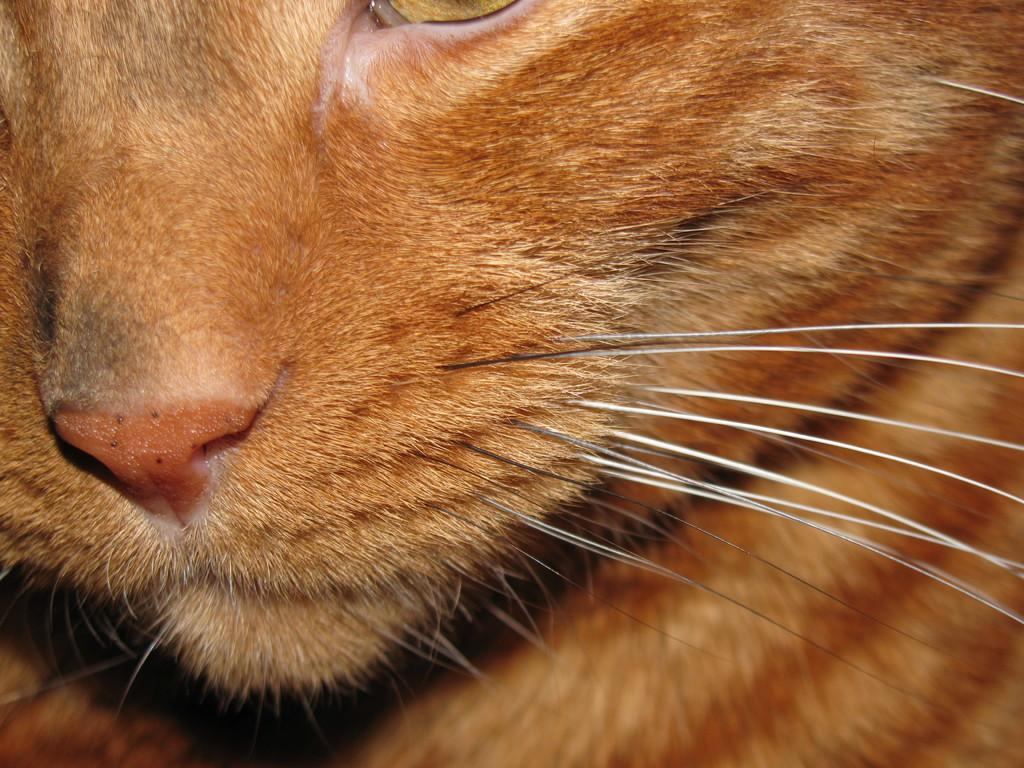What type of animal is in the image? There is a cat in the image. What color is the cat? The cat is light brown in color. What facial features does the cat have? The cat has a nose, whiskers, and an eye. What type of science experiment is the cat conducting in the image? There is no science experiment present in the image; it simply features a light brown cat with a nose, whiskers, and an eye. 